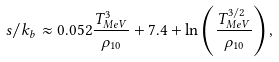<formula> <loc_0><loc_0><loc_500><loc_500>s / k _ { b } \approx 0 . 0 5 2 \frac { T _ { M e V } ^ { 3 } } { \rho _ { 1 0 } } + 7 . 4 + \ln \left ( \frac { T _ { M e V } ^ { 3 / 2 } } { \rho _ { 1 0 } } \right ) ,</formula> 